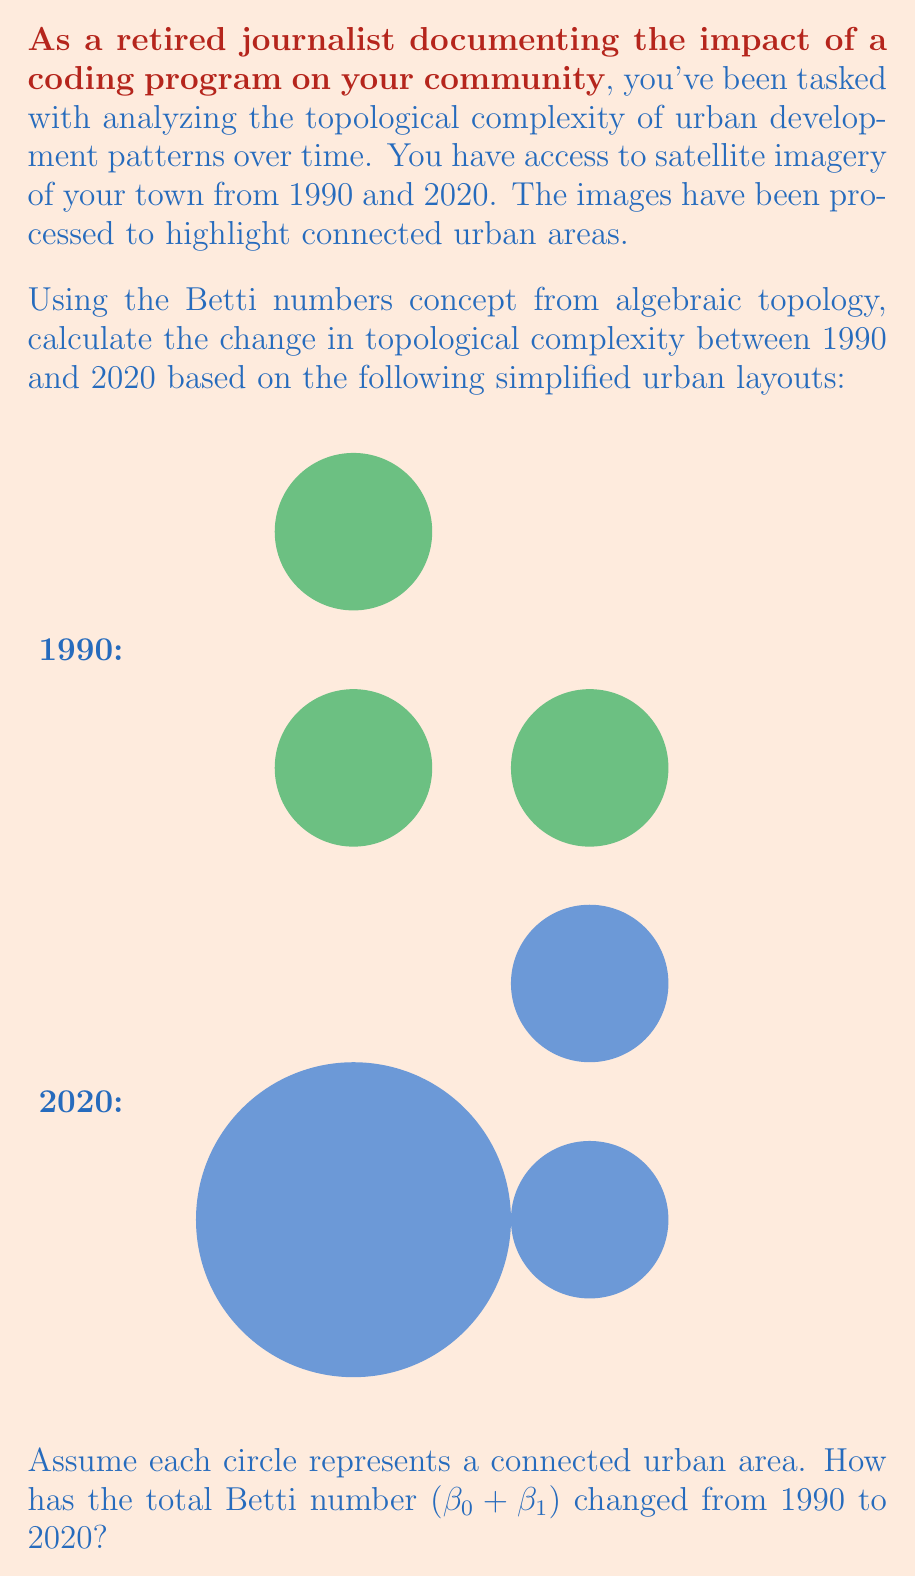Solve this math problem. To solve this problem, we need to understand and calculate the Betti numbers for each year:

1. Betti numbers:
   - β₀: number of connected components
   - β₁: number of 2-dimensional holes

2. For 1990:
   - β₀ = 3 (three separate circles)
   - β₁ = 0 (no holes)
   - Total Betti number: 3 + 0 = 3

3. For 2020:
   - β₀ = 3 (three separate urban areas)
   - β₁ = 1 (one hole formed by the three urban areas)
   - Total Betti number: 3 + 1 = 4

4. Change in total Betti number:
   $\Delta \text{Betti} = \text{Betti}_{2020} - \text{Betti}_{1990}$
   $\Delta \text{Betti} = 4 - 3 = 1$

The positive change indicates an increase in topological complexity, reflecting the development of a more intricate urban structure over time.
Answer: 1 